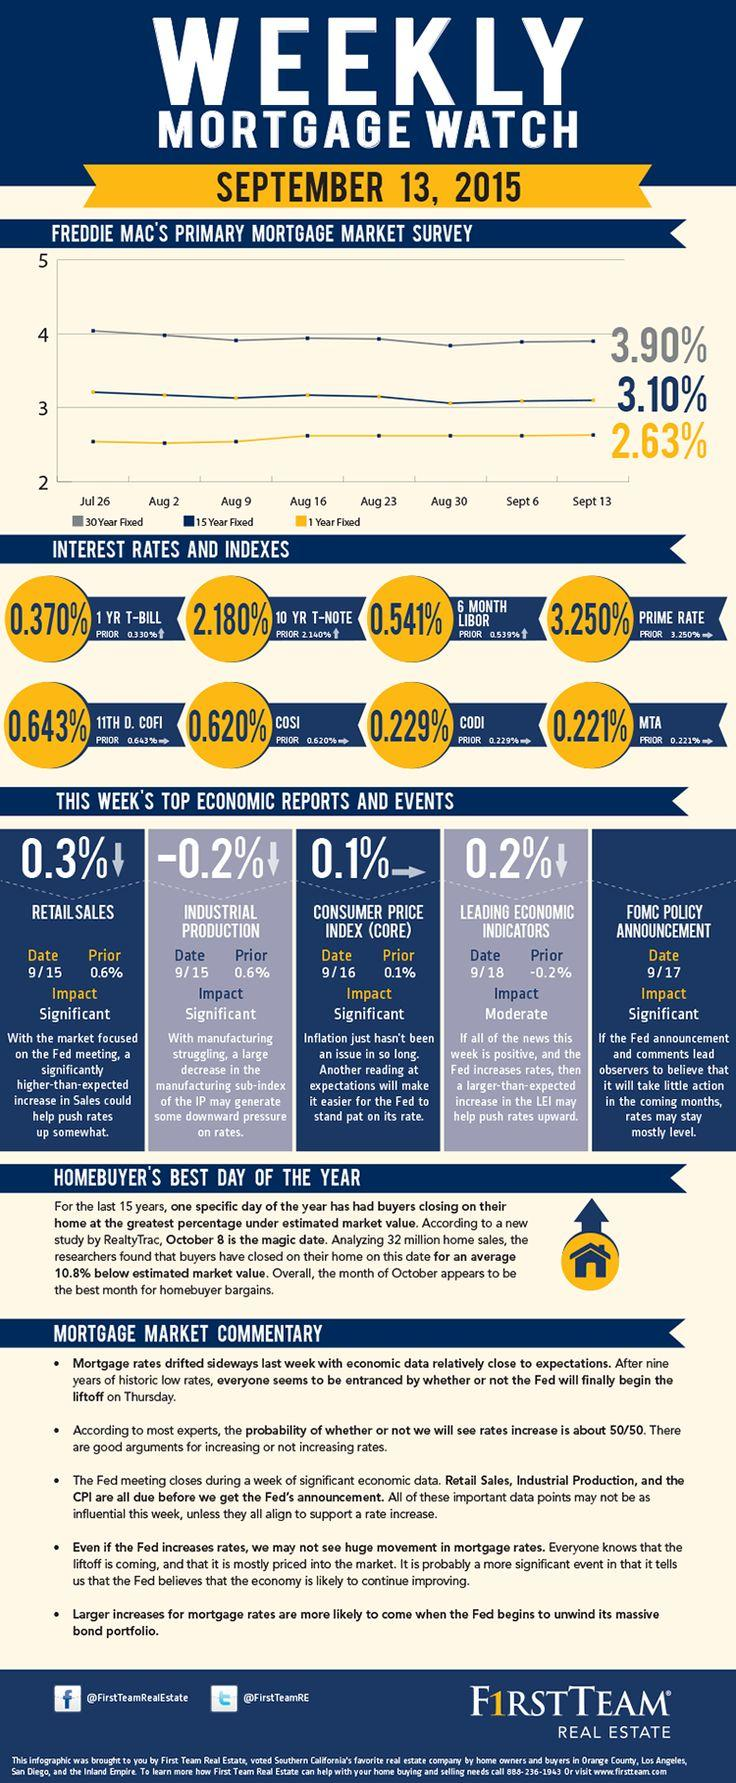Draw attention to some important aspects in this diagram. On September 16th, the Consumer Price Index remained at a value of 0.1%. On September 15th, retail sales decreased by 0.3%. 